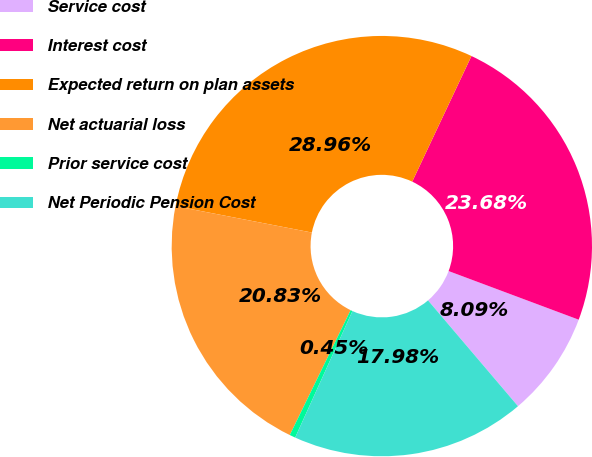<chart> <loc_0><loc_0><loc_500><loc_500><pie_chart><fcel>Service cost<fcel>Interest cost<fcel>Expected return on plan assets<fcel>Net actuarial loss<fcel>Prior service cost<fcel>Net Periodic Pension Cost<nl><fcel>8.09%<fcel>23.68%<fcel>28.96%<fcel>20.83%<fcel>0.45%<fcel>17.98%<nl></chart> 